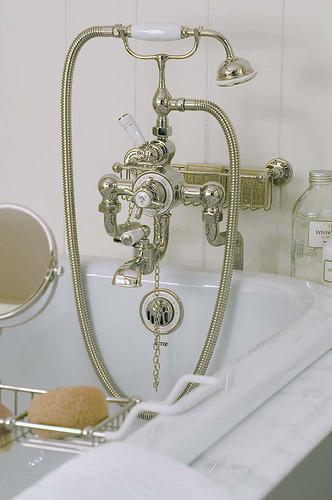How many bottles are on the sink?
Give a very brief answer. 2. 